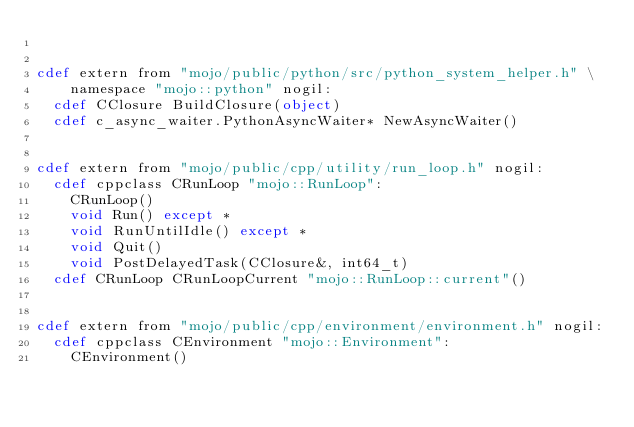<code> <loc_0><loc_0><loc_500><loc_500><_Cython_>

cdef extern from "mojo/public/python/src/python_system_helper.h" \
    namespace "mojo::python" nogil:
  cdef CClosure BuildClosure(object)
  cdef c_async_waiter.PythonAsyncWaiter* NewAsyncWaiter()


cdef extern from "mojo/public/cpp/utility/run_loop.h" nogil:
  cdef cppclass CRunLoop "mojo::RunLoop":
    CRunLoop()
    void Run() except *
    void RunUntilIdle() except *
    void Quit()
    void PostDelayedTask(CClosure&, int64_t)
  cdef CRunLoop CRunLoopCurrent "mojo::RunLoop::current"()


cdef extern from "mojo/public/cpp/environment/environment.h" nogil:
  cdef cppclass CEnvironment "mojo::Environment":
    CEnvironment()
</code> 